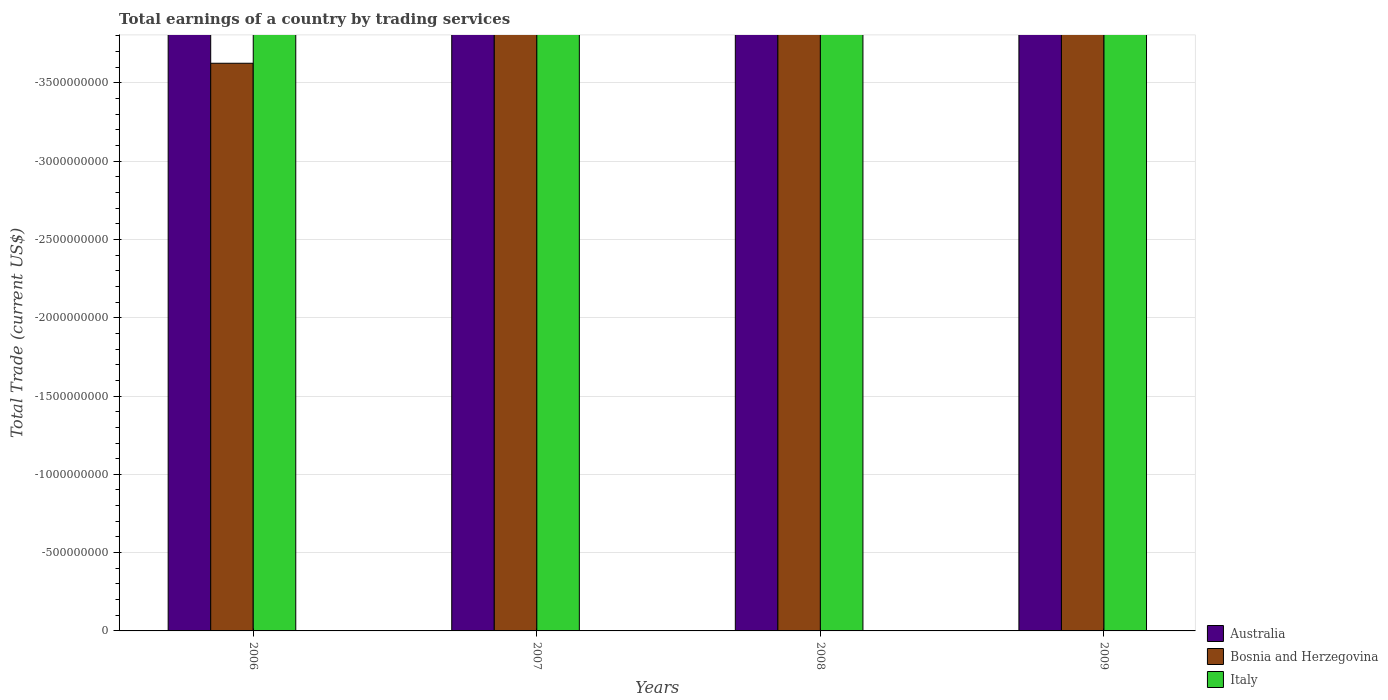Are the number of bars on each tick of the X-axis equal?
Your answer should be very brief. Yes. What is the label of the 3rd group of bars from the left?
Offer a very short reply. 2008. What is the total earnings in Bosnia and Herzegovina in 2009?
Ensure brevity in your answer.  0. Across all years, what is the minimum total earnings in Bosnia and Herzegovina?
Give a very brief answer. 0. What is the total total earnings in Australia in the graph?
Provide a short and direct response. 0. In how many years, is the total earnings in Bosnia and Herzegovina greater than the average total earnings in Bosnia and Herzegovina taken over all years?
Your answer should be very brief. 0. Is it the case that in every year, the sum of the total earnings in Italy and total earnings in Australia is greater than the total earnings in Bosnia and Herzegovina?
Your answer should be very brief. No. What is the difference between two consecutive major ticks on the Y-axis?
Offer a very short reply. 5.00e+08. Are the values on the major ticks of Y-axis written in scientific E-notation?
Make the answer very short. No. Does the graph contain any zero values?
Make the answer very short. Yes. Where does the legend appear in the graph?
Keep it short and to the point. Bottom right. How are the legend labels stacked?
Provide a succinct answer. Vertical. What is the title of the graph?
Give a very brief answer. Total earnings of a country by trading services. What is the label or title of the X-axis?
Provide a succinct answer. Years. What is the label or title of the Y-axis?
Your answer should be compact. Total Trade (current US$). What is the Total Trade (current US$) of Australia in 2006?
Provide a succinct answer. 0. What is the Total Trade (current US$) in Bosnia and Herzegovina in 2006?
Provide a short and direct response. 0. What is the Total Trade (current US$) in Italy in 2006?
Your response must be concise. 0. What is the Total Trade (current US$) in Australia in 2007?
Your response must be concise. 0. What is the Total Trade (current US$) in Bosnia and Herzegovina in 2007?
Your response must be concise. 0. What is the Total Trade (current US$) of Bosnia and Herzegovina in 2008?
Your response must be concise. 0. What is the Total Trade (current US$) in Italy in 2008?
Your answer should be compact. 0. What is the Total Trade (current US$) of Australia in 2009?
Keep it short and to the point. 0. What is the Total Trade (current US$) in Bosnia and Herzegovina in 2009?
Keep it short and to the point. 0. What is the total Total Trade (current US$) in Australia in the graph?
Your answer should be compact. 0. What is the average Total Trade (current US$) in Australia per year?
Your response must be concise. 0. What is the average Total Trade (current US$) in Bosnia and Herzegovina per year?
Keep it short and to the point. 0. What is the average Total Trade (current US$) of Italy per year?
Offer a very short reply. 0. 